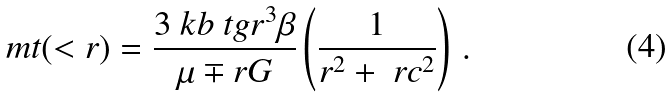Convert formula to latex. <formula><loc_0><loc_0><loc_500><loc_500>\ m t ( < r ) = \frac { 3 \ k b \ t g r ^ { 3 } \beta } { \mu \mp r G } \left ( \frac { 1 } { r ^ { 2 } + \ r c ^ { 2 } } \right ) \, .</formula> 